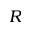<formula> <loc_0><loc_0><loc_500><loc_500>R</formula> 